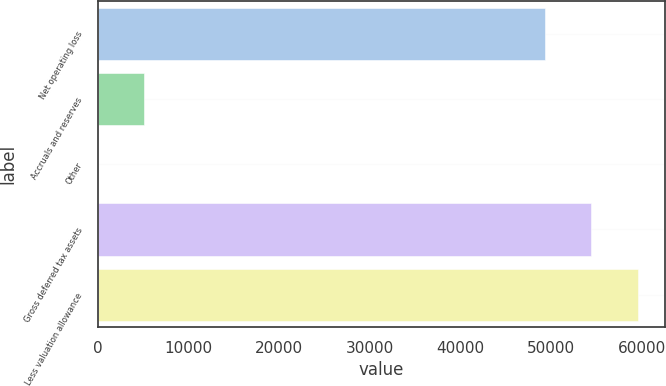Convert chart. <chart><loc_0><loc_0><loc_500><loc_500><bar_chart><fcel>Net operating loss<fcel>Accruals and reserves<fcel>Other<fcel>Gross deferred tax assets<fcel>Less valuation allowance<nl><fcel>49337<fcel>5117.3<fcel>14<fcel>54440.3<fcel>59543.6<nl></chart> 